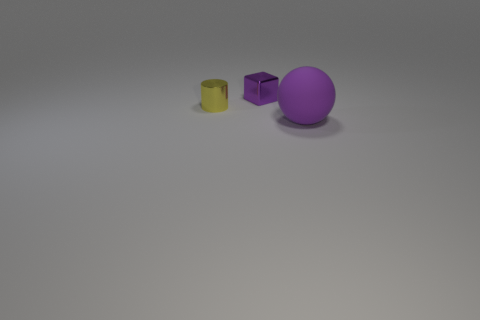Add 1 big blue things. How many objects exist? 4 Subtract all balls. How many objects are left? 2 Subtract 0 red balls. How many objects are left? 3 Subtract all large blue metal objects. Subtract all tiny blocks. How many objects are left? 2 Add 3 tiny purple metallic blocks. How many tiny purple metallic blocks are left? 4 Add 3 green matte blocks. How many green matte blocks exist? 3 